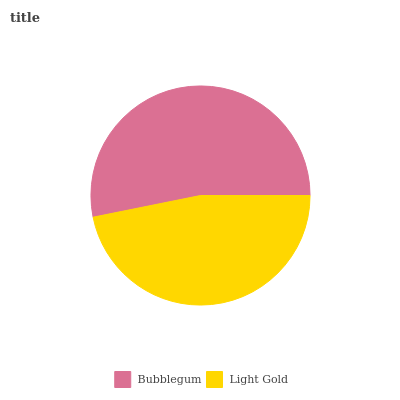Is Light Gold the minimum?
Answer yes or no. Yes. Is Bubblegum the maximum?
Answer yes or no. Yes. Is Light Gold the maximum?
Answer yes or no. No. Is Bubblegum greater than Light Gold?
Answer yes or no. Yes. Is Light Gold less than Bubblegum?
Answer yes or no. Yes. Is Light Gold greater than Bubblegum?
Answer yes or no. No. Is Bubblegum less than Light Gold?
Answer yes or no. No. Is Bubblegum the high median?
Answer yes or no. Yes. Is Light Gold the low median?
Answer yes or no. Yes. Is Light Gold the high median?
Answer yes or no. No. Is Bubblegum the low median?
Answer yes or no. No. 